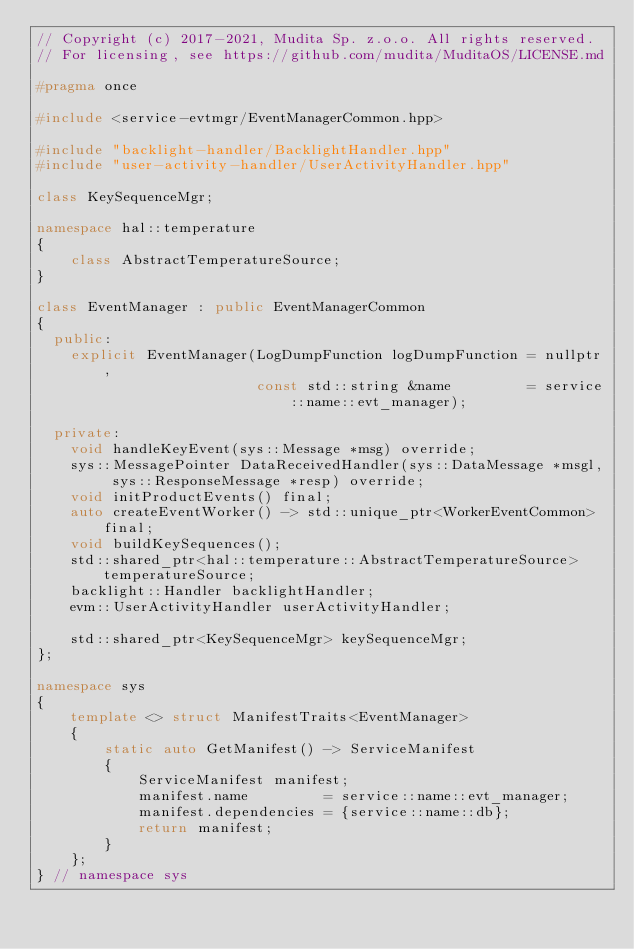<code> <loc_0><loc_0><loc_500><loc_500><_C++_>// Copyright (c) 2017-2021, Mudita Sp. z.o.o. All rights reserved.
// For licensing, see https://github.com/mudita/MuditaOS/LICENSE.md

#pragma once

#include <service-evtmgr/EventManagerCommon.hpp>

#include "backlight-handler/BacklightHandler.hpp"
#include "user-activity-handler/UserActivityHandler.hpp"

class KeySequenceMgr;

namespace hal::temperature
{
    class AbstractTemperatureSource;
}

class EventManager : public EventManagerCommon
{
  public:
    explicit EventManager(LogDumpFunction logDumpFunction = nullptr,
                          const std::string &name         = service::name::evt_manager);

  private:
    void handleKeyEvent(sys::Message *msg) override;
    sys::MessagePointer DataReceivedHandler(sys::DataMessage *msgl, sys::ResponseMessage *resp) override;
    void initProductEvents() final;
    auto createEventWorker() -> std::unique_ptr<WorkerEventCommon> final;
    void buildKeySequences();
    std::shared_ptr<hal::temperature::AbstractTemperatureSource> temperatureSource;
    backlight::Handler backlightHandler;
    evm::UserActivityHandler userActivityHandler;

    std::shared_ptr<KeySequenceMgr> keySequenceMgr;
};

namespace sys
{
    template <> struct ManifestTraits<EventManager>
    {
        static auto GetManifest() -> ServiceManifest
        {
            ServiceManifest manifest;
            manifest.name         = service::name::evt_manager;
            manifest.dependencies = {service::name::db};
            return manifest;
        }
    };
} // namespace sys
</code> 